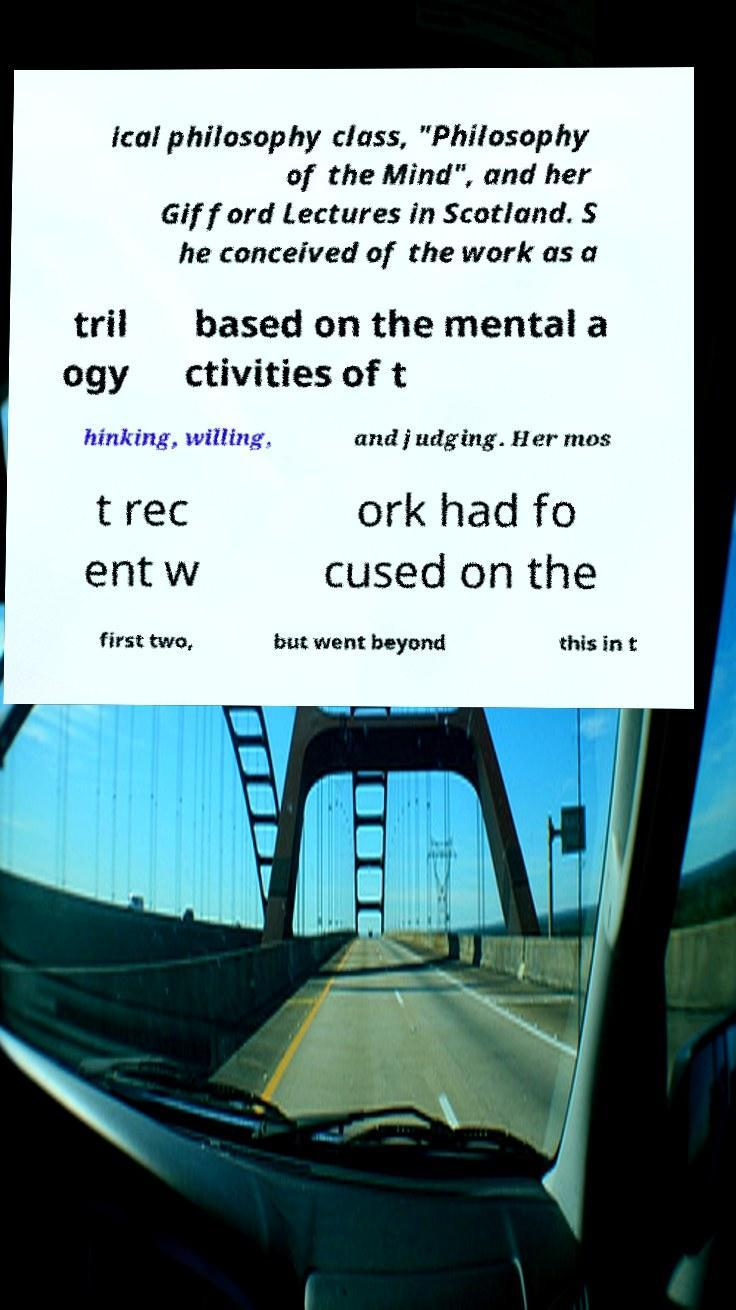Can you accurately transcribe the text from the provided image for me? ical philosophy class, "Philosophy of the Mind", and her Gifford Lectures in Scotland. S he conceived of the work as a tril ogy based on the mental a ctivities of t hinking, willing, and judging. Her mos t rec ent w ork had fo cused on the first two, but went beyond this in t 